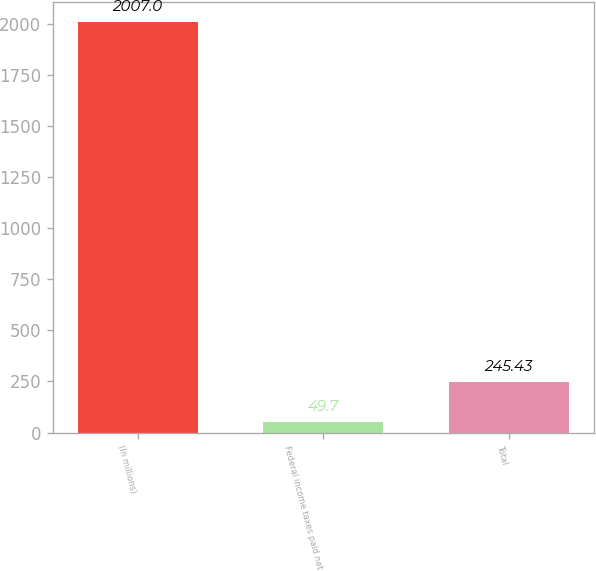Convert chart to OTSL. <chart><loc_0><loc_0><loc_500><loc_500><bar_chart><fcel>(In millions)<fcel>Federal income taxes paid net<fcel>Total<nl><fcel>2007<fcel>49.7<fcel>245.43<nl></chart> 